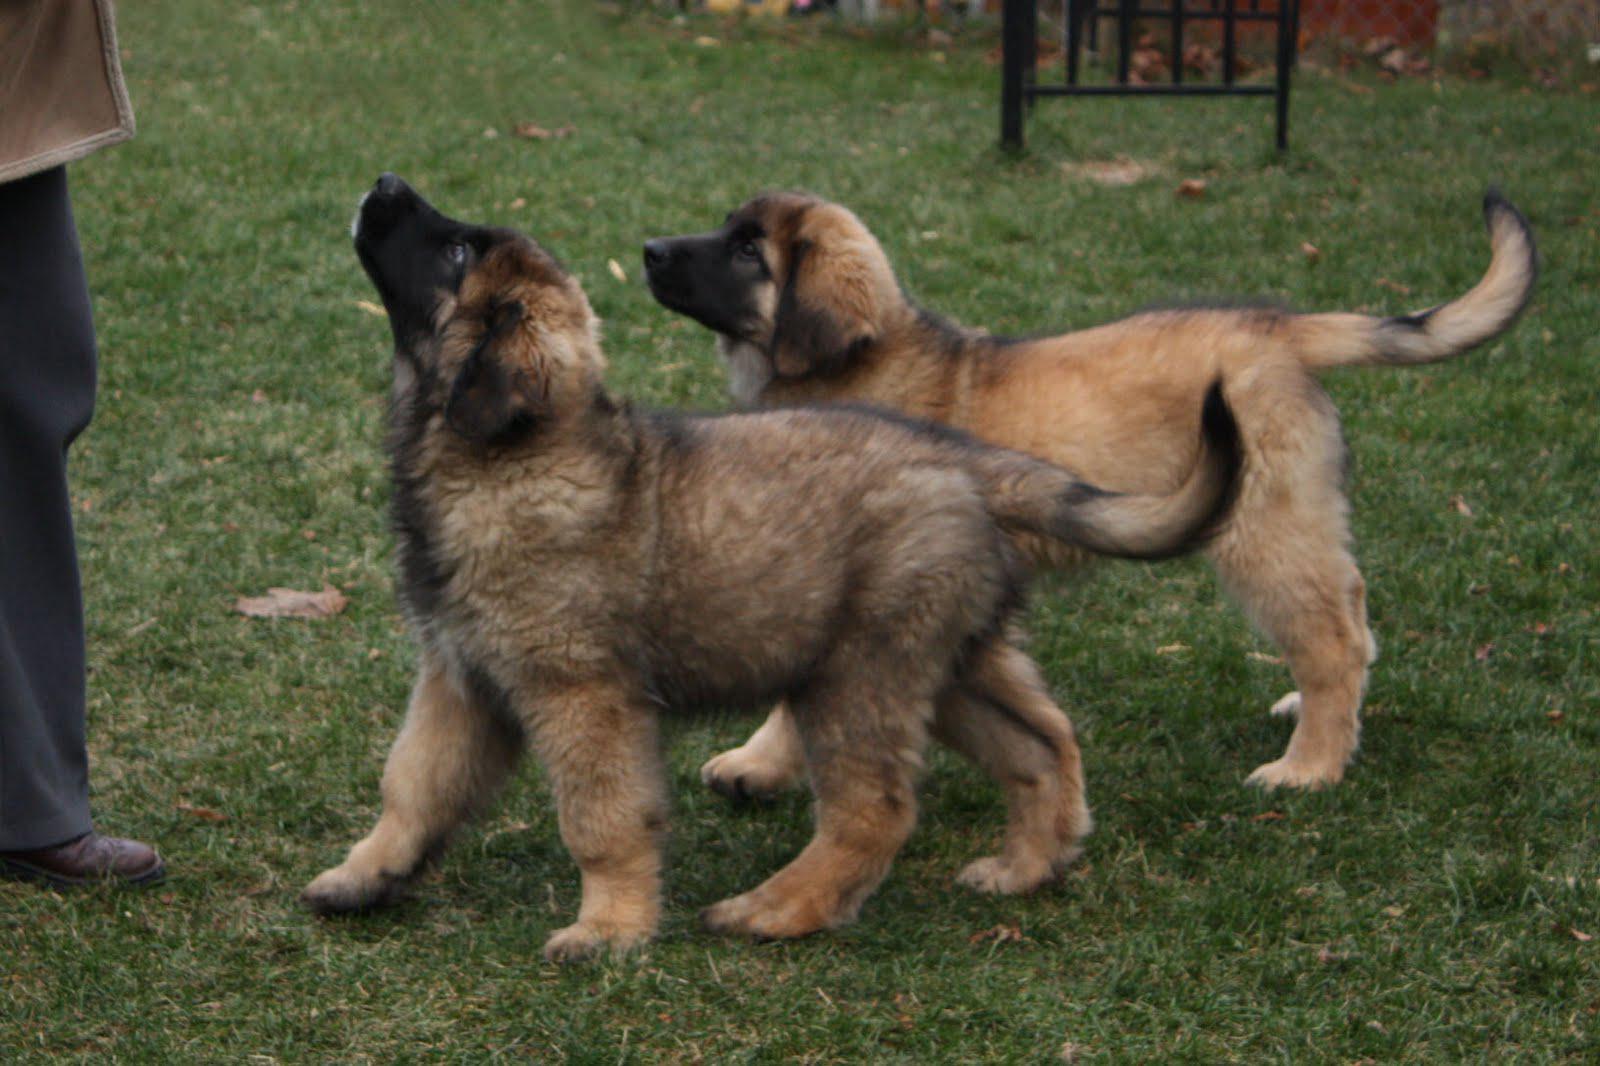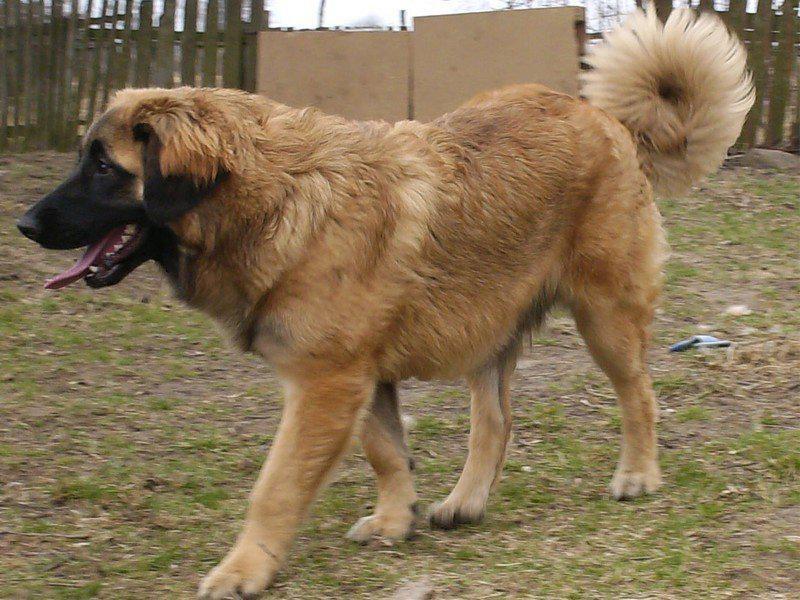The first image is the image on the left, the second image is the image on the right. Considering the images on both sides, is "two puppies are atanding next to each other on the grass looking upward" valid? Answer yes or no. Yes. The first image is the image on the left, the second image is the image on the right. Given the left and right images, does the statement "Only one dog is sitting in the grass." hold true? Answer yes or no. No. 